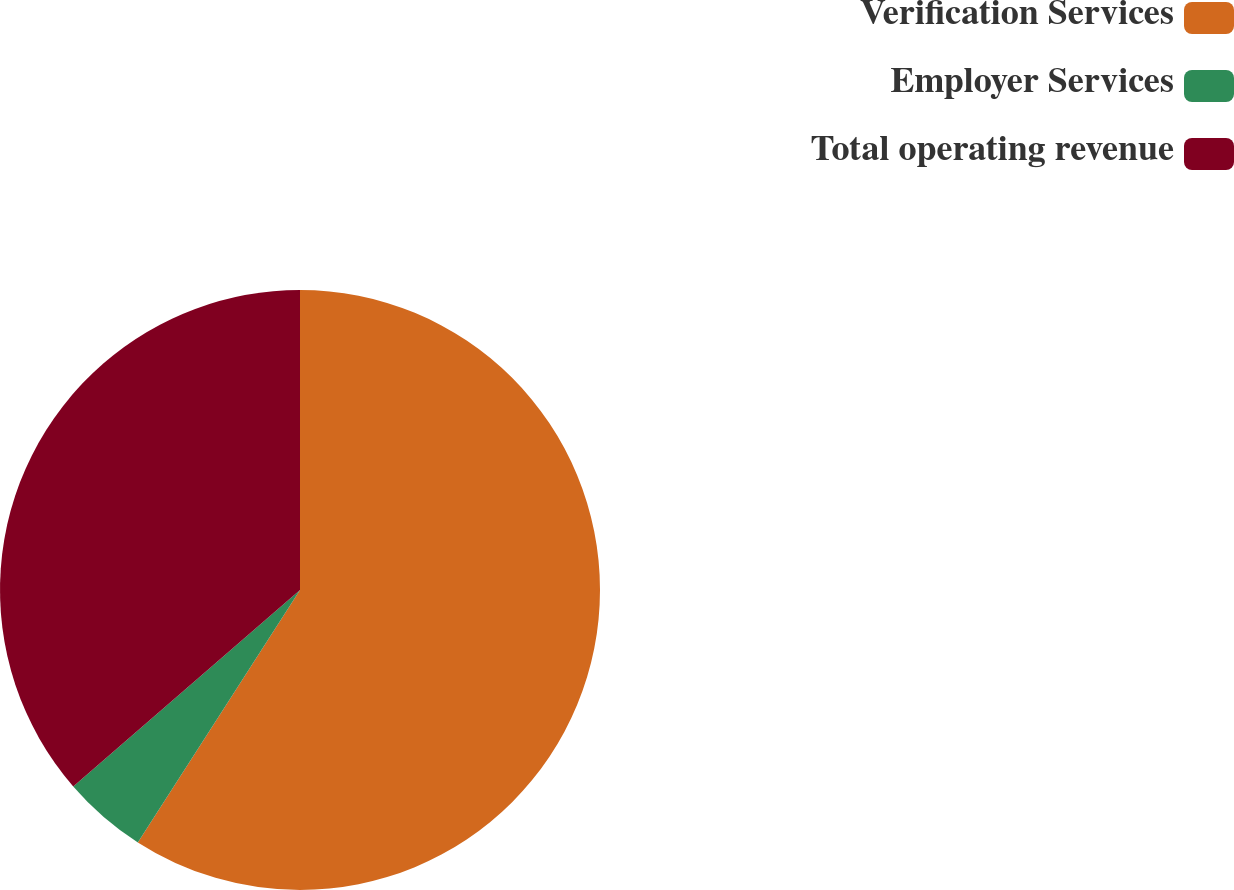Convert chart. <chart><loc_0><loc_0><loc_500><loc_500><pie_chart><fcel>Verification Services<fcel>Employer Services<fcel>Total operating revenue<nl><fcel>59.09%<fcel>4.55%<fcel>36.36%<nl></chart> 